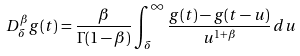<formula> <loc_0><loc_0><loc_500><loc_500>D ^ { \beta } _ { \delta } g ( t ) = \frac { \beta } { \Gamma ( 1 - \beta ) } \int _ { \delta } ^ { \infty } \frac { g ( t ) - g ( t - u ) } { u ^ { 1 + \beta } } \, d u</formula> 